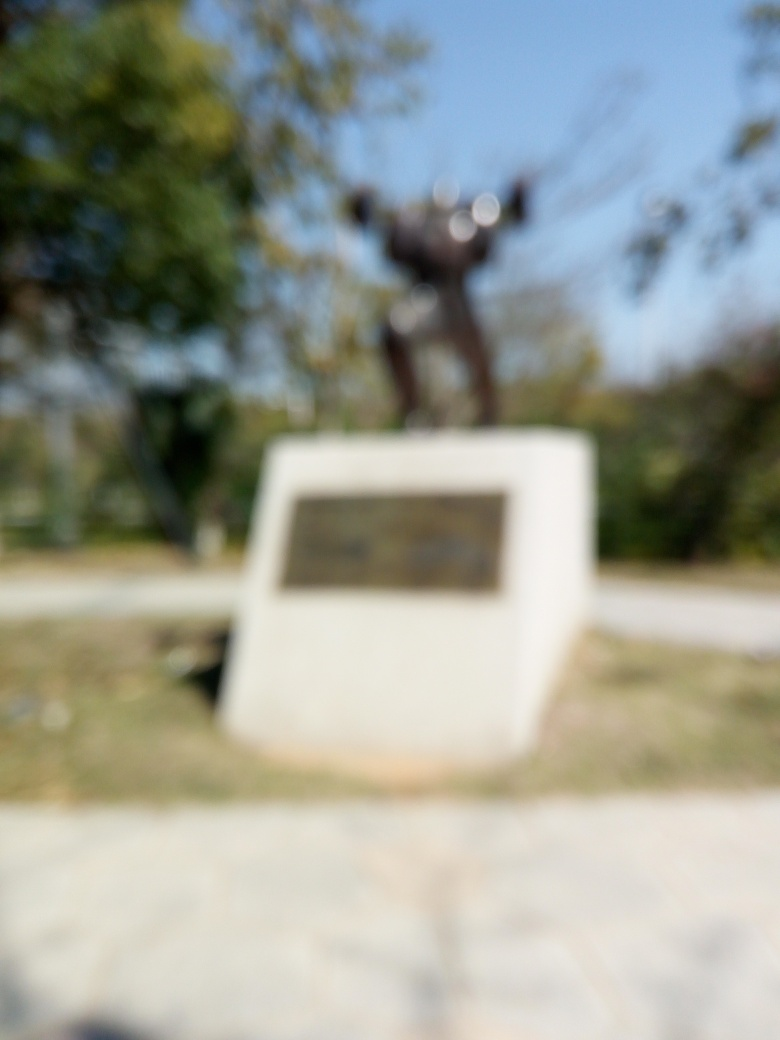What is the quality of this image? The quality of the image is very poor due to significant blurring, possibly from camera shake or out-of-focus issues, making it difficult to identify details clearly, such as text or finer features of the statue present. 